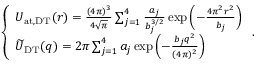Convert formula to latex. <formula><loc_0><loc_0><loc_500><loc_500>\begin{array} { r } { \left \{ \begin{array} { l l } { U _ { a t , D T } ( r ) = { \frac { ( 4 \pi ) ^ { 3 } } { 4 \sqrt { \pi } } } \sum _ { j = 1 } ^ { 4 } { \frac { a _ { j } } { b _ { j } ^ { 3 / 2 } } } \exp \left ( - { \frac { 4 \pi ^ { 2 } r ^ { 2 } } { b _ { j } } } \right ) } \\ { \widetilde { U } _ { D T } ( q ) = 2 \pi \sum _ { j = 1 } ^ { 4 } a _ { j } \exp \left ( - { \frac { b _ { j } q ^ { 2 } } { ( 4 \pi ) ^ { 2 } } } \right ) } \end{array} . } \end{array}</formula> 